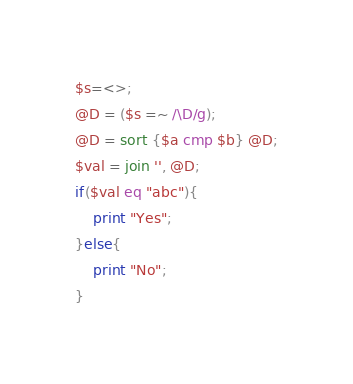Convert code to text. <code><loc_0><loc_0><loc_500><loc_500><_Perl_>$s=<>;
@D = ($s =~ /\D/g);
@D = sort {$a cmp $b} @D;
$val = join '', @D;
if($val eq "abc"){
	print "Yes";
}else{
	print "No";
}</code> 